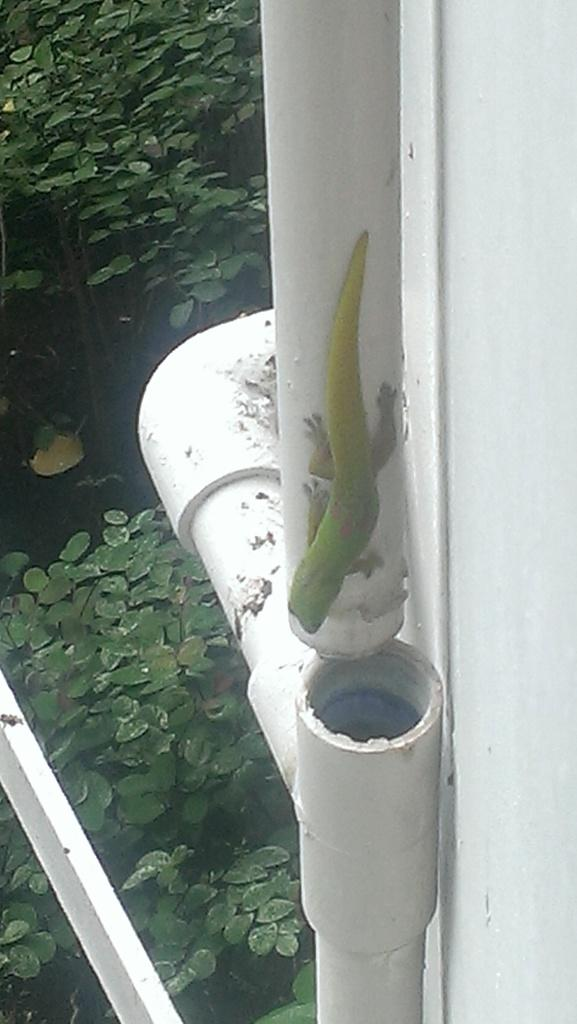What is the main structure visible in the image? There is a wall in the image. What can be seen on the right side of the wall? There are pipes on the right side of the image. What type of vegetation is visible in the background of the image? There are plants in the background of the image. What else can be seen in the background of the image? Leaves are present in the background of the image. What type of beef is being discovered in the image? There is no beef present in the image, and therefore no discovery of beef can be observed. 